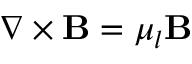Convert formula to latex. <formula><loc_0><loc_0><loc_500><loc_500>\nabla \times B = \mu _ { l } B</formula> 